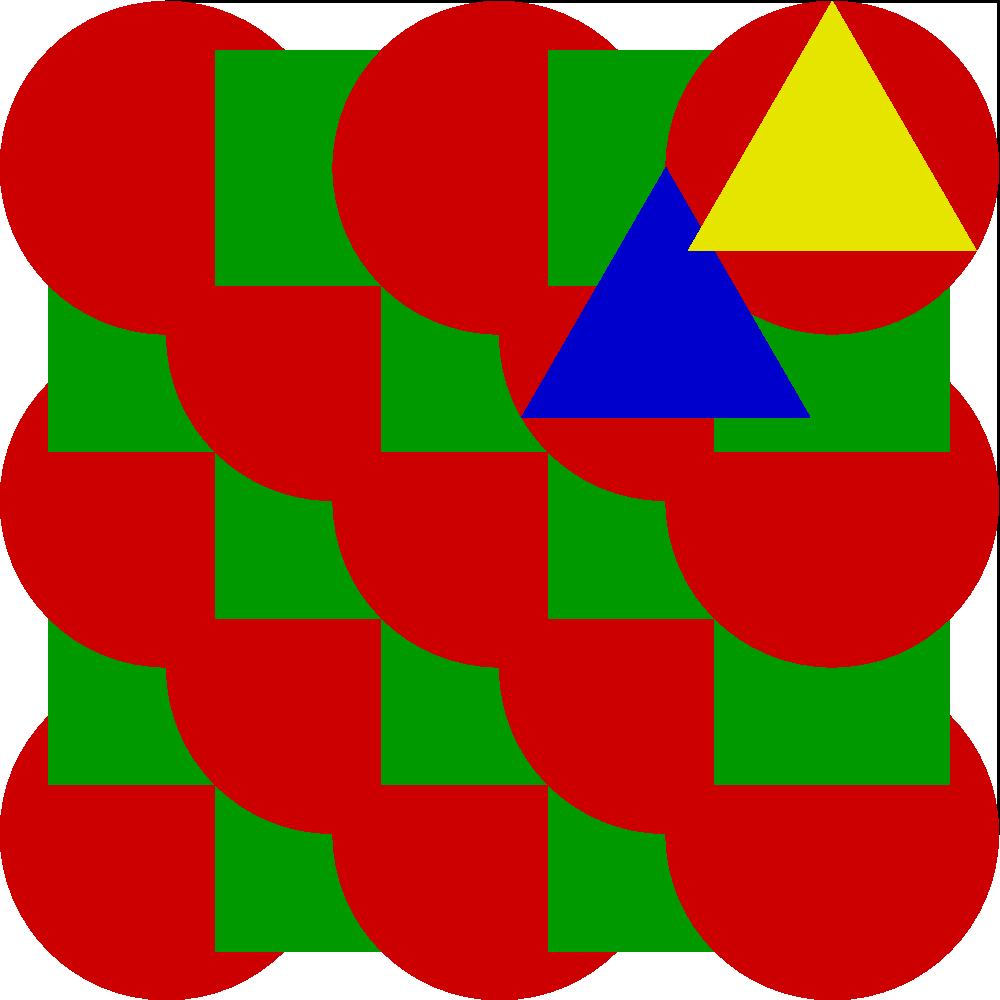In this traditional Bulgarian folk pattern, which type of geometric shape breaks the overall symmetry of the design? To identify the shape that breaks the symmetry in this Bulgarian folk pattern, let's analyze the design step-by-step:

1. The pattern is based on a 5x5 grid within a square.
2. The main elements of the pattern are:
   a) Red circles
   b) Green squares
   c) Blue triangle
   d) Yellow triangle

3. The red circles and green squares are arranged in a chessboard-like pattern, which is symmetrical.

4. The blue and yellow triangles are placed in the bottom-right corner of the design.

5. These triangles break the overall symmetry of the pattern because:
   a) They are not repeated in other corners of the design.
   b) They introduce a new shape (triangle) that is not present in the rest of the pattern.
   c) Their colors (blue and yellow) are not used elsewhere in the design.

6. Among the shapes present (circle, square, triangle), the triangle is the only one that appears asymmetrically and disrupts the pattern's overall symmetry.

Therefore, the triangle is the geometric shape that breaks the overall symmetry of the design.
Answer: Triangle 